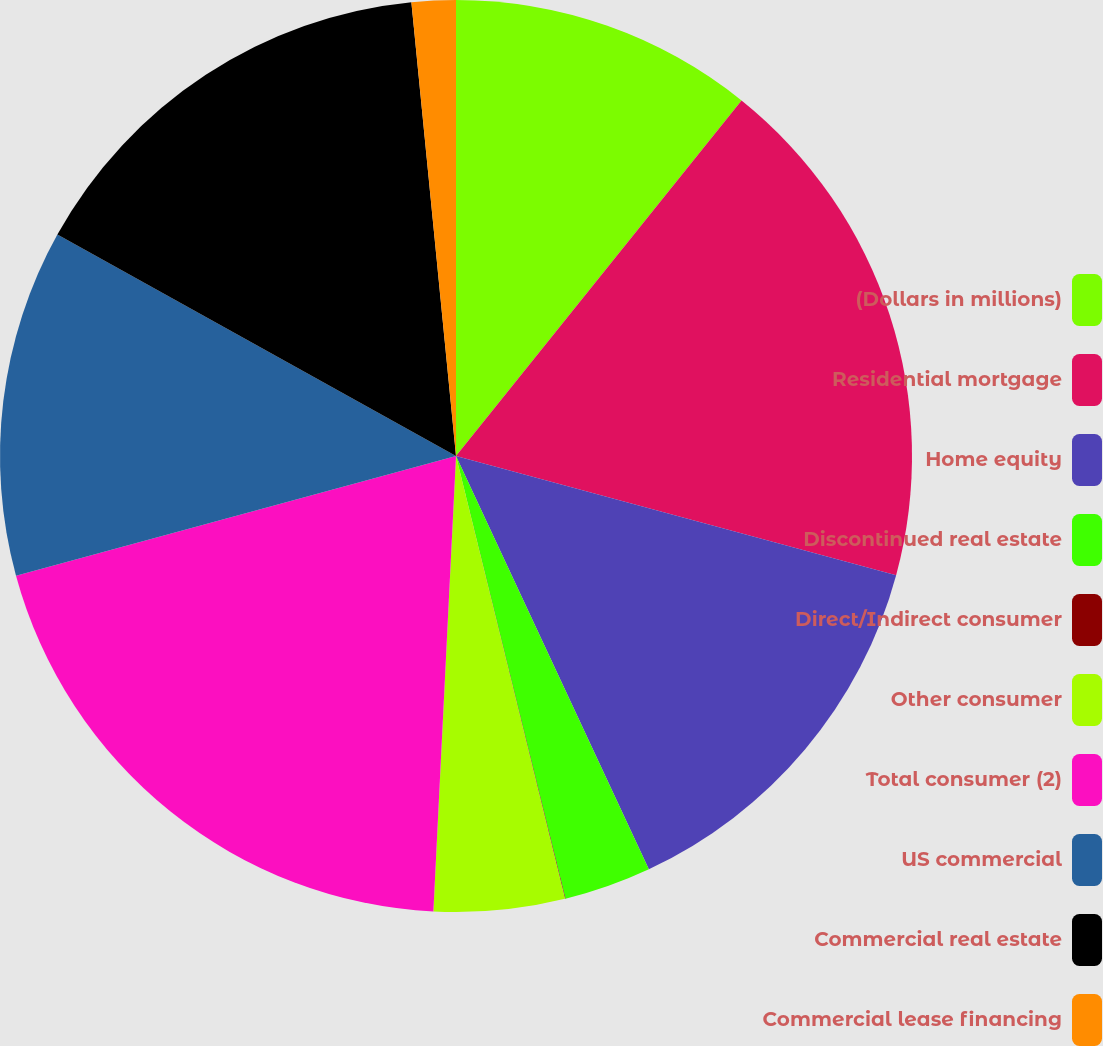Convert chart to OTSL. <chart><loc_0><loc_0><loc_500><loc_500><pie_chart><fcel>(Dollars in millions)<fcel>Residential mortgage<fcel>Home equity<fcel>Discontinued real estate<fcel>Direct/Indirect consumer<fcel>Other consumer<fcel>Total consumer (2)<fcel>US commercial<fcel>Commercial real estate<fcel>Commercial lease financing<nl><fcel>10.77%<fcel>18.44%<fcel>13.84%<fcel>3.09%<fcel>0.02%<fcel>4.63%<fcel>19.98%<fcel>12.3%<fcel>15.37%<fcel>1.56%<nl></chart> 